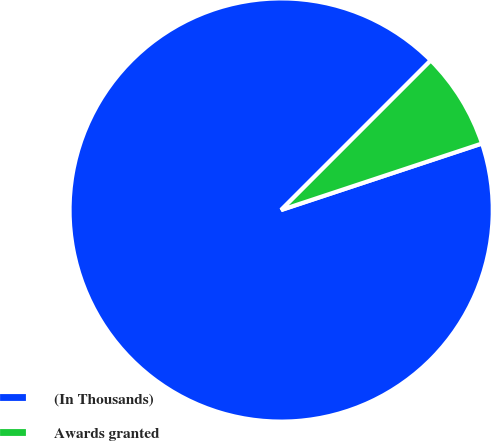Convert chart. <chart><loc_0><loc_0><loc_500><loc_500><pie_chart><fcel>(In Thousands)<fcel>Awards granted<nl><fcel>92.59%<fcel>7.41%<nl></chart> 